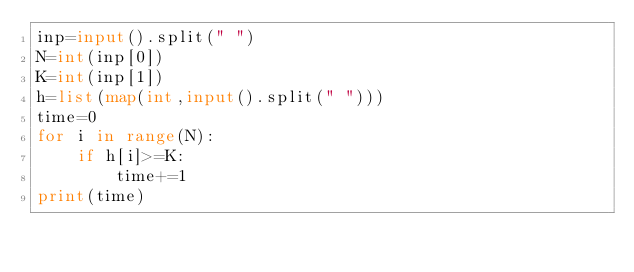Convert code to text. <code><loc_0><loc_0><loc_500><loc_500><_Python_>inp=input().split(" ")
N=int(inp[0])
K=int(inp[1])
h=list(map(int,input().split(" ")))
time=0
for i in range(N):
    if h[i]>=K:
        time+=1
print(time)</code> 